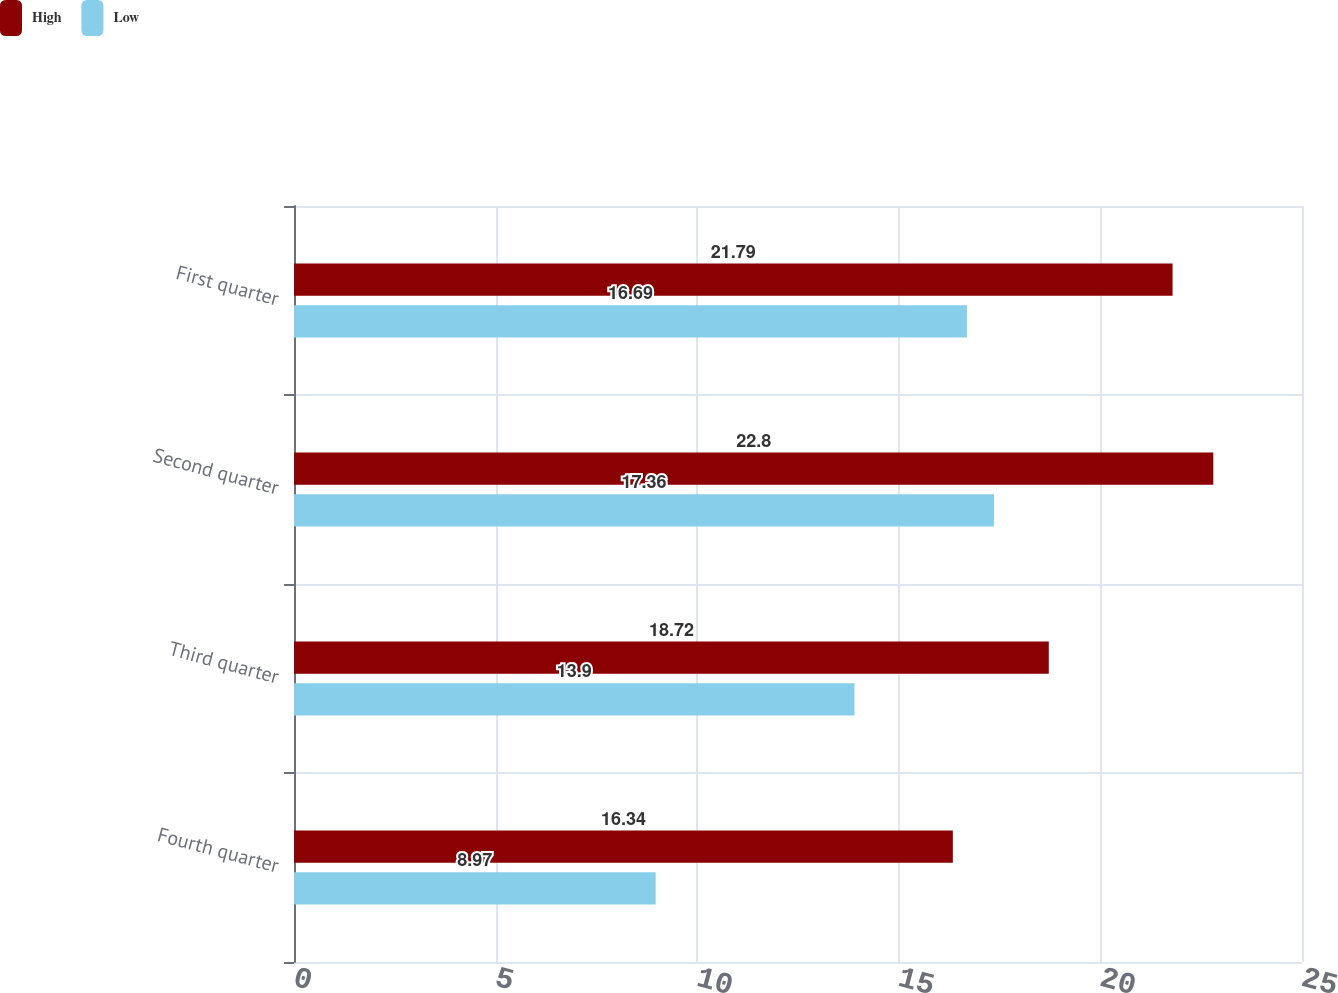Convert chart to OTSL. <chart><loc_0><loc_0><loc_500><loc_500><stacked_bar_chart><ecel><fcel>Fourth quarter<fcel>Third quarter<fcel>Second quarter<fcel>First quarter<nl><fcel>High<fcel>16.34<fcel>18.72<fcel>22.8<fcel>21.79<nl><fcel>Low<fcel>8.97<fcel>13.9<fcel>17.36<fcel>16.69<nl></chart> 